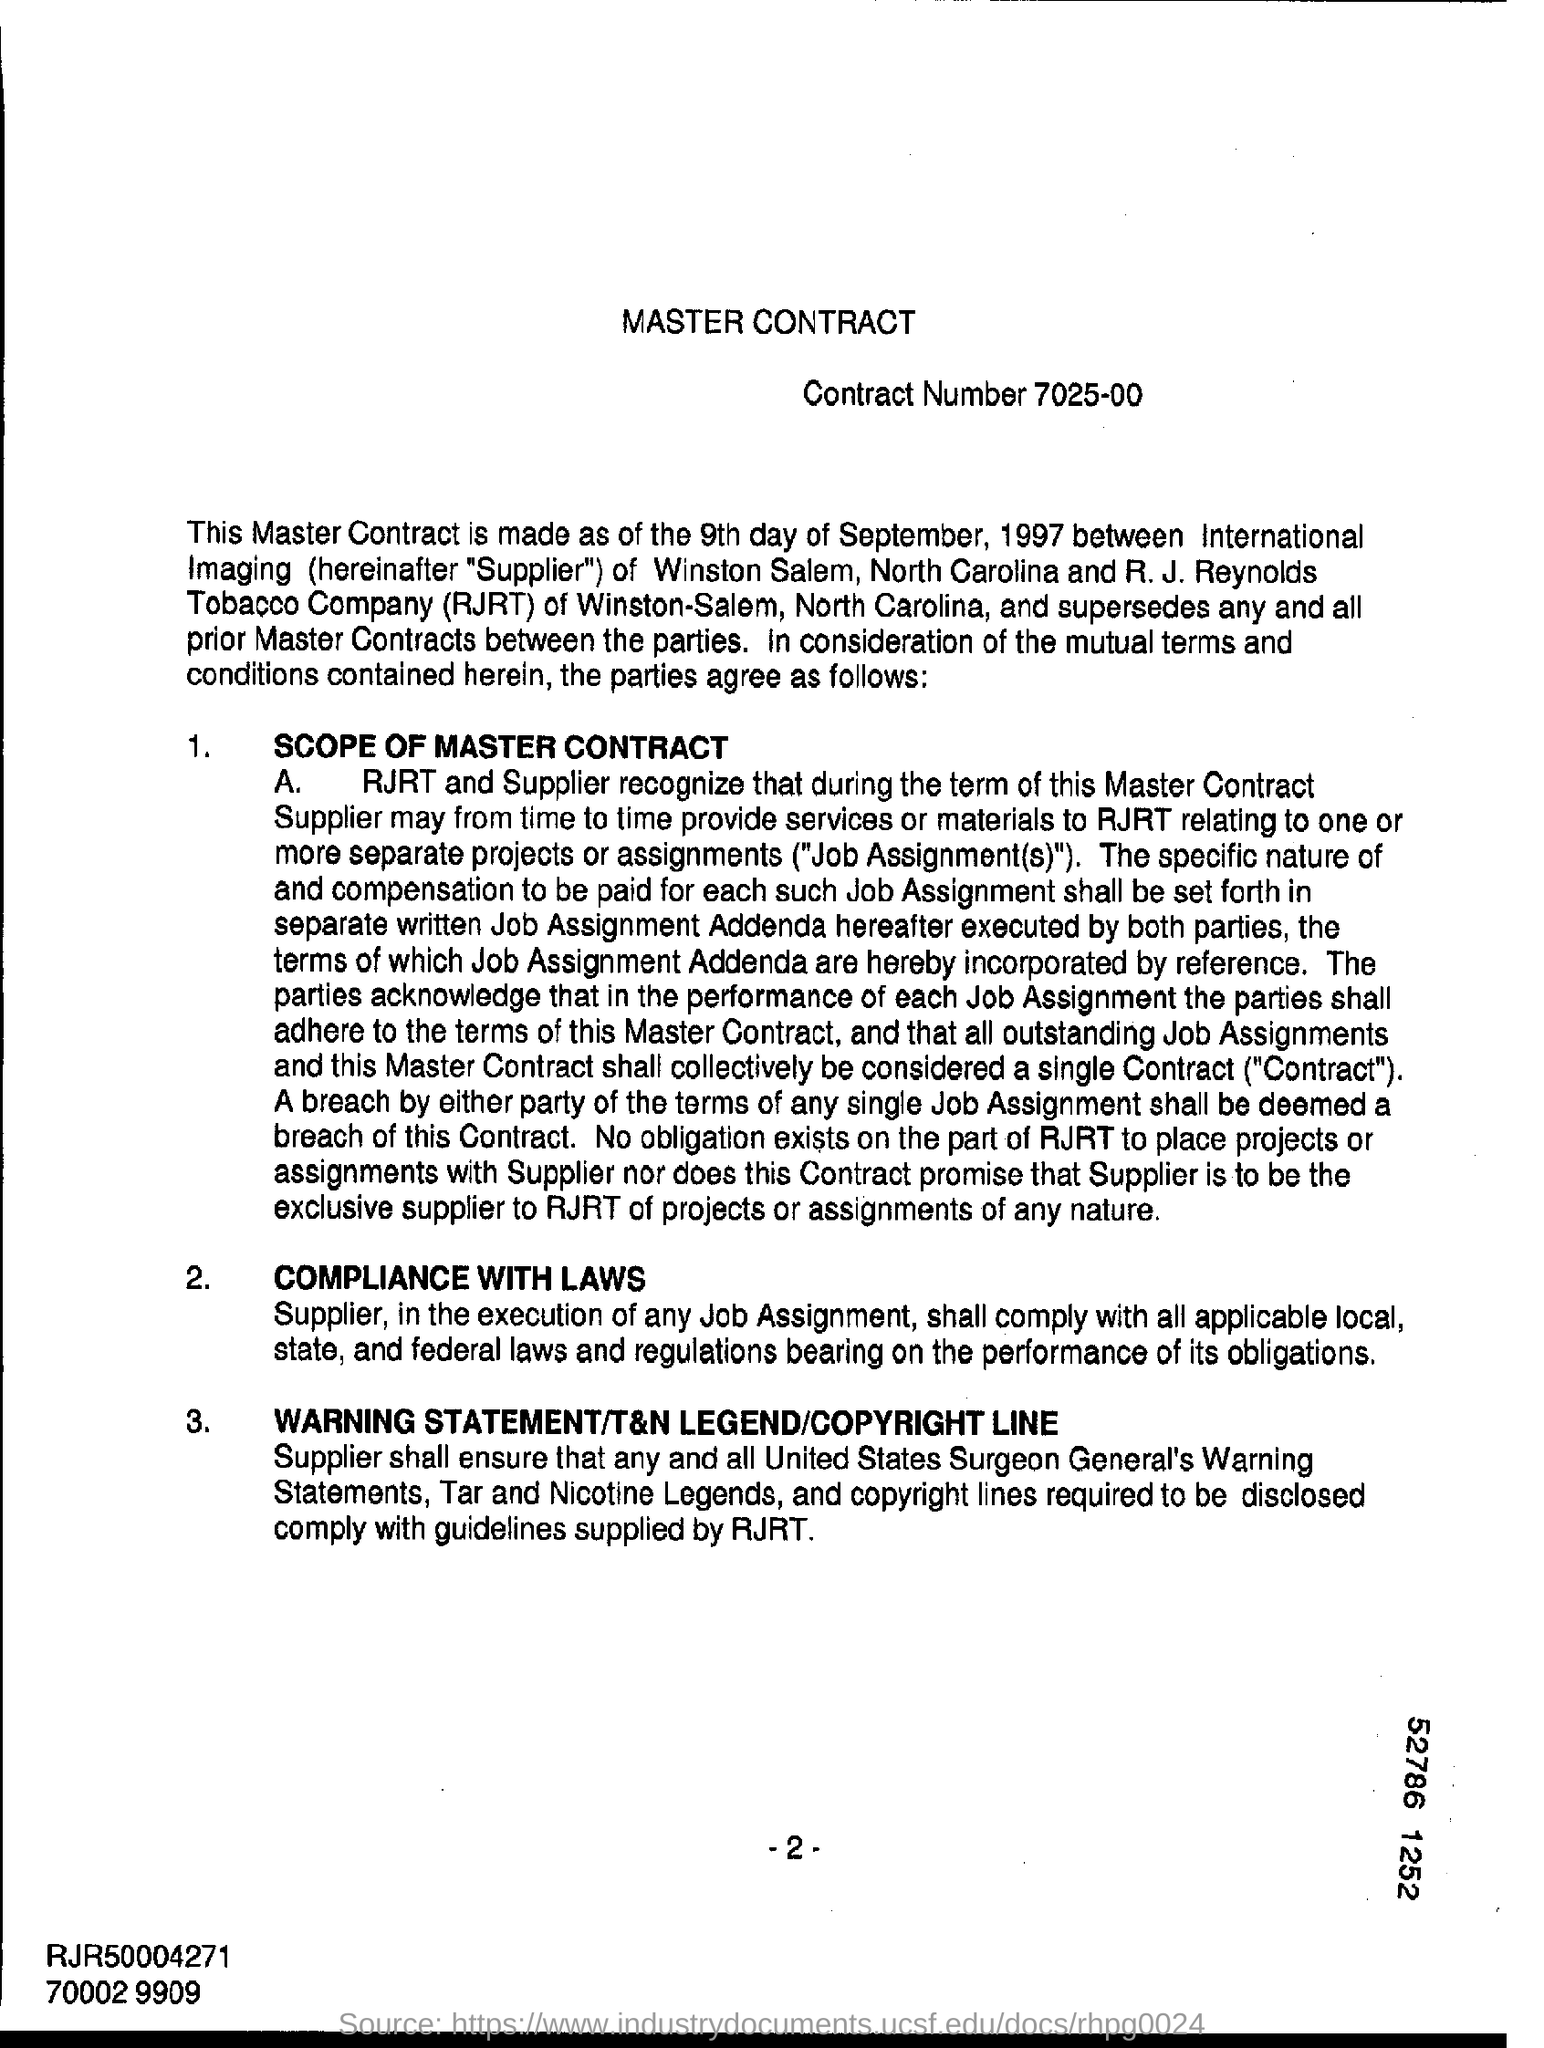List a handful of essential elements in this visual. R.J. Reynolds Tobacco Company is an acronym, represented as RJRT. The heading of the page is "The Master Contract. The contract number is 7025-00. 